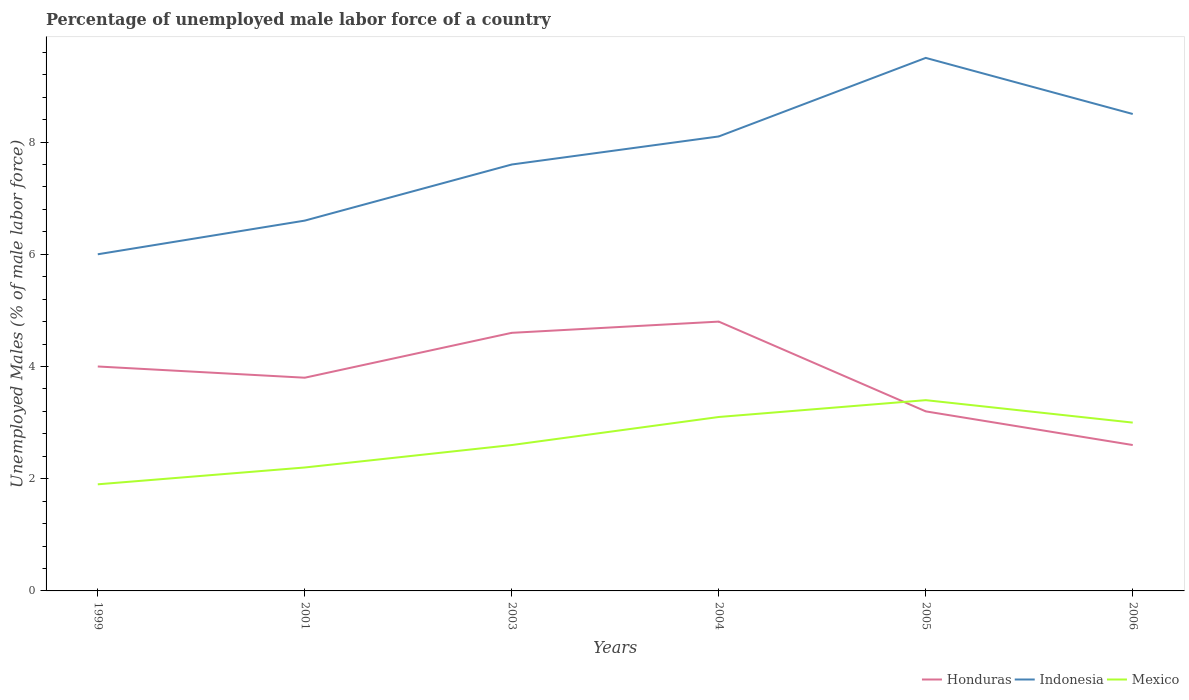Does the line corresponding to Mexico intersect with the line corresponding to Honduras?
Your response must be concise. Yes. Is the number of lines equal to the number of legend labels?
Your response must be concise. Yes. Across all years, what is the maximum percentage of unemployed male labor force in Honduras?
Your answer should be very brief. 2.6. In which year was the percentage of unemployed male labor force in Indonesia maximum?
Your answer should be very brief. 1999. What is the total percentage of unemployed male labor force in Indonesia in the graph?
Make the answer very short. -0.5. What is the difference between the highest and the second highest percentage of unemployed male labor force in Indonesia?
Offer a terse response. 3.5. What is the difference between the highest and the lowest percentage of unemployed male labor force in Mexico?
Your response must be concise. 3. What is the difference between two consecutive major ticks on the Y-axis?
Your answer should be very brief. 2. Does the graph contain any zero values?
Your answer should be very brief. No. Does the graph contain grids?
Make the answer very short. No. Where does the legend appear in the graph?
Offer a terse response. Bottom right. How many legend labels are there?
Give a very brief answer. 3. What is the title of the graph?
Your answer should be very brief. Percentage of unemployed male labor force of a country. What is the label or title of the X-axis?
Make the answer very short. Years. What is the label or title of the Y-axis?
Your response must be concise. Unemployed Males (% of male labor force). What is the Unemployed Males (% of male labor force) in Indonesia in 1999?
Make the answer very short. 6. What is the Unemployed Males (% of male labor force) of Mexico in 1999?
Your answer should be compact. 1.9. What is the Unemployed Males (% of male labor force) in Honduras in 2001?
Offer a very short reply. 3.8. What is the Unemployed Males (% of male labor force) in Indonesia in 2001?
Your answer should be compact. 6.6. What is the Unemployed Males (% of male labor force) in Mexico in 2001?
Provide a short and direct response. 2.2. What is the Unemployed Males (% of male labor force) of Honduras in 2003?
Provide a succinct answer. 4.6. What is the Unemployed Males (% of male labor force) of Indonesia in 2003?
Your answer should be compact. 7.6. What is the Unemployed Males (% of male labor force) of Mexico in 2003?
Your answer should be compact. 2.6. What is the Unemployed Males (% of male labor force) in Honduras in 2004?
Provide a succinct answer. 4.8. What is the Unemployed Males (% of male labor force) in Indonesia in 2004?
Your answer should be very brief. 8.1. What is the Unemployed Males (% of male labor force) of Mexico in 2004?
Make the answer very short. 3.1. What is the Unemployed Males (% of male labor force) in Honduras in 2005?
Ensure brevity in your answer.  3.2. What is the Unemployed Males (% of male labor force) in Mexico in 2005?
Make the answer very short. 3.4. What is the Unemployed Males (% of male labor force) in Honduras in 2006?
Provide a succinct answer. 2.6. What is the Unemployed Males (% of male labor force) of Indonesia in 2006?
Provide a succinct answer. 8.5. What is the Unemployed Males (% of male labor force) in Mexico in 2006?
Your answer should be compact. 3. Across all years, what is the maximum Unemployed Males (% of male labor force) of Honduras?
Make the answer very short. 4.8. Across all years, what is the maximum Unemployed Males (% of male labor force) in Indonesia?
Provide a succinct answer. 9.5. Across all years, what is the maximum Unemployed Males (% of male labor force) in Mexico?
Your answer should be very brief. 3.4. Across all years, what is the minimum Unemployed Males (% of male labor force) in Honduras?
Provide a succinct answer. 2.6. Across all years, what is the minimum Unemployed Males (% of male labor force) of Indonesia?
Give a very brief answer. 6. Across all years, what is the minimum Unemployed Males (% of male labor force) in Mexico?
Make the answer very short. 1.9. What is the total Unemployed Males (% of male labor force) of Honduras in the graph?
Your response must be concise. 23. What is the total Unemployed Males (% of male labor force) of Indonesia in the graph?
Give a very brief answer. 46.3. What is the total Unemployed Males (% of male labor force) in Mexico in the graph?
Ensure brevity in your answer.  16.2. What is the difference between the Unemployed Males (% of male labor force) of Honduras in 1999 and that in 2003?
Offer a terse response. -0.6. What is the difference between the Unemployed Males (% of male labor force) in Indonesia in 1999 and that in 2004?
Offer a terse response. -2.1. What is the difference between the Unemployed Males (% of male labor force) of Honduras in 1999 and that in 2005?
Your answer should be very brief. 0.8. What is the difference between the Unemployed Males (% of male labor force) in Honduras in 1999 and that in 2006?
Provide a short and direct response. 1.4. What is the difference between the Unemployed Males (% of male labor force) of Honduras in 2001 and that in 2003?
Ensure brevity in your answer.  -0.8. What is the difference between the Unemployed Males (% of male labor force) in Indonesia in 2001 and that in 2003?
Offer a terse response. -1. What is the difference between the Unemployed Males (% of male labor force) of Mexico in 2001 and that in 2004?
Your answer should be compact. -0.9. What is the difference between the Unemployed Males (% of male labor force) in Honduras in 2001 and that in 2006?
Your answer should be compact. 1.2. What is the difference between the Unemployed Males (% of male labor force) of Indonesia in 2001 and that in 2006?
Give a very brief answer. -1.9. What is the difference between the Unemployed Males (% of male labor force) in Honduras in 2003 and that in 2004?
Give a very brief answer. -0.2. What is the difference between the Unemployed Males (% of male labor force) in Indonesia in 2003 and that in 2004?
Provide a short and direct response. -0.5. What is the difference between the Unemployed Males (% of male labor force) in Indonesia in 2003 and that in 2005?
Your answer should be compact. -1.9. What is the difference between the Unemployed Males (% of male labor force) of Honduras in 2003 and that in 2006?
Offer a very short reply. 2. What is the difference between the Unemployed Males (% of male labor force) in Indonesia in 2003 and that in 2006?
Give a very brief answer. -0.9. What is the difference between the Unemployed Males (% of male labor force) of Mexico in 2003 and that in 2006?
Your answer should be very brief. -0.4. What is the difference between the Unemployed Males (% of male labor force) in Indonesia in 2004 and that in 2005?
Provide a succinct answer. -1.4. What is the difference between the Unemployed Males (% of male labor force) of Mexico in 2004 and that in 2005?
Offer a very short reply. -0.3. What is the difference between the Unemployed Males (% of male labor force) in Mexico in 2004 and that in 2006?
Your answer should be compact. 0.1. What is the difference between the Unemployed Males (% of male labor force) of Honduras in 2005 and that in 2006?
Provide a succinct answer. 0.6. What is the difference between the Unemployed Males (% of male labor force) of Indonesia in 2005 and that in 2006?
Your answer should be compact. 1. What is the difference between the Unemployed Males (% of male labor force) of Honduras in 1999 and the Unemployed Males (% of male labor force) of Mexico in 2001?
Provide a succinct answer. 1.8. What is the difference between the Unemployed Males (% of male labor force) in Indonesia in 1999 and the Unemployed Males (% of male labor force) in Mexico in 2001?
Your response must be concise. 3.8. What is the difference between the Unemployed Males (% of male labor force) of Honduras in 1999 and the Unemployed Males (% of male labor force) of Indonesia in 2003?
Give a very brief answer. -3.6. What is the difference between the Unemployed Males (% of male labor force) of Honduras in 1999 and the Unemployed Males (% of male labor force) of Mexico in 2003?
Your response must be concise. 1.4. What is the difference between the Unemployed Males (% of male labor force) in Honduras in 1999 and the Unemployed Males (% of male labor force) in Indonesia in 2004?
Ensure brevity in your answer.  -4.1. What is the difference between the Unemployed Males (% of male labor force) in Honduras in 1999 and the Unemployed Males (% of male labor force) in Mexico in 2004?
Keep it short and to the point. 0.9. What is the difference between the Unemployed Males (% of male labor force) of Indonesia in 1999 and the Unemployed Males (% of male labor force) of Mexico in 2004?
Your response must be concise. 2.9. What is the difference between the Unemployed Males (% of male labor force) of Honduras in 1999 and the Unemployed Males (% of male labor force) of Mexico in 2005?
Keep it short and to the point. 0.6. What is the difference between the Unemployed Males (% of male labor force) of Indonesia in 1999 and the Unemployed Males (% of male labor force) of Mexico in 2005?
Offer a very short reply. 2.6. What is the difference between the Unemployed Males (% of male labor force) in Honduras in 1999 and the Unemployed Males (% of male labor force) in Indonesia in 2006?
Your answer should be compact. -4.5. What is the difference between the Unemployed Males (% of male labor force) in Honduras in 1999 and the Unemployed Males (% of male labor force) in Mexico in 2006?
Your answer should be compact. 1. What is the difference between the Unemployed Males (% of male labor force) in Indonesia in 1999 and the Unemployed Males (% of male labor force) in Mexico in 2006?
Make the answer very short. 3. What is the difference between the Unemployed Males (% of male labor force) in Indonesia in 2001 and the Unemployed Males (% of male labor force) in Mexico in 2003?
Offer a very short reply. 4. What is the difference between the Unemployed Males (% of male labor force) in Honduras in 2001 and the Unemployed Males (% of male labor force) in Indonesia in 2004?
Your answer should be compact. -4.3. What is the difference between the Unemployed Males (% of male labor force) of Honduras in 2001 and the Unemployed Males (% of male labor force) of Mexico in 2004?
Your answer should be compact. 0.7. What is the difference between the Unemployed Males (% of male labor force) of Honduras in 2001 and the Unemployed Males (% of male labor force) of Indonesia in 2005?
Offer a very short reply. -5.7. What is the difference between the Unemployed Males (% of male labor force) of Honduras in 2001 and the Unemployed Males (% of male labor force) of Mexico in 2005?
Your response must be concise. 0.4. What is the difference between the Unemployed Males (% of male labor force) in Indonesia in 2001 and the Unemployed Males (% of male labor force) in Mexico in 2005?
Ensure brevity in your answer.  3.2. What is the difference between the Unemployed Males (% of male labor force) of Honduras in 2001 and the Unemployed Males (% of male labor force) of Indonesia in 2006?
Make the answer very short. -4.7. What is the difference between the Unemployed Males (% of male labor force) in Honduras in 2001 and the Unemployed Males (% of male labor force) in Mexico in 2006?
Keep it short and to the point. 0.8. What is the difference between the Unemployed Males (% of male labor force) in Indonesia in 2001 and the Unemployed Males (% of male labor force) in Mexico in 2006?
Provide a short and direct response. 3.6. What is the difference between the Unemployed Males (% of male labor force) in Honduras in 2003 and the Unemployed Males (% of male labor force) in Indonesia in 2004?
Your response must be concise. -3.5. What is the difference between the Unemployed Males (% of male labor force) in Indonesia in 2003 and the Unemployed Males (% of male labor force) in Mexico in 2004?
Your answer should be compact. 4.5. What is the difference between the Unemployed Males (% of male labor force) of Honduras in 2003 and the Unemployed Males (% of male labor force) of Mexico in 2005?
Make the answer very short. 1.2. What is the difference between the Unemployed Males (% of male labor force) of Honduras in 2003 and the Unemployed Males (% of male labor force) of Indonesia in 2006?
Make the answer very short. -3.9. What is the difference between the Unemployed Males (% of male labor force) in Honduras in 2003 and the Unemployed Males (% of male labor force) in Mexico in 2006?
Keep it short and to the point. 1.6. What is the difference between the Unemployed Males (% of male labor force) in Indonesia in 2003 and the Unemployed Males (% of male labor force) in Mexico in 2006?
Make the answer very short. 4.6. What is the difference between the Unemployed Males (% of male labor force) in Honduras in 2004 and the Unemployed Males (% of male labor force) in Indonesia in 2005?
Ensure brevity in your answer.  -4.7. What is the difference between the Unemployed Males (% of male labor force) in Honduras in 2004 and the Unemployed Males (% of male labor force) in Mexico in 2006?
Your response must be concise. 1.8. What is the difference between the Unemployed Males (% of male labor force) in Indonesia in 2004 and the Unemployed Males (% of male labor force) in Mexico in 2006?
Ensure brevity in your answer.  5.1. What is the average Unemployed Males (% of male labor force) of Honduras per year?
Ensure brevity in your answer.  3.83. What is the average Unemployed Males (% of male labor force) of Indonesia per year?
Your answer should be very brief. 7.72. What is the average Unemployed Males (% of male labor force) of Mexico per year?
Offer a very short reply. 2.7. In the year 1999, what is the difference between the Unemployed Males (% of male labor force) in Honduras and Unemployed Males (% of male labor force) in Indonesia?
Your answer should be very brief. -2. In the year 1999, what is the difference between the Unemployed Males (% of male labor force) of Honduras and Unemployed Males (% of male labor force) of Mexico?
Offer a terse response. 2.1. In the year 2001, what is the difference between the Unemployed Males (% of male labor force) in Honduras and Unemployed Males (% of male labor force) in Indonesia?
Provide a short and direct response. -2.8. In the year 2003, what is the difference between the Unemployed Males (% of male labor force) in Honduras and Unemployed Males (% of male labor force) in Indonesia?
Give a very brief answer. -3. In the year 2003, what is the difference between the Unemployed Males (% of male labor force) in Indonesia and Unemployed Males (% of male labor force) in Mexico?
Keep it short and to the point. 5. In the year 2004, what is the difference between the Unemployed Males (% of male labor force) in Honduras and Unemployed Males (% of male labor force) in Indonesia?
Provide a short and direct response. -3.3. In the year 2004, what is the difference between the Unemployed Males (% of male labor force) in Honduras and Unemployed Males (% of male labor force) in Mexico?
Ensure brevity in your answer.  1.7. In the year 2004, what is the difference between the Unemployed Males (% of male labor force) of Indonesia and Unemployed Males (% of male labor force) of Mexico?
Your answer should be very brief. 5. In the year 2005, what is the difference between the Unemployed Males (% of male labor force) in Indonesia and Unemployed Males (% of male labor force) in Mexico?
Your response must be concise. 6.1. In the year 2006, what is the difference between the Unemployed Males (% of male labor force) of Indonesia and Unemployed Males (% of male labor force) of Mexico?
Provide a succinct answer. 5.5. What is the ratio of the Unemployed Males (% of male labor force) in Honduras in 1999 to that in 2001?
Offer a very short reply. 1.05. What is the ratio of the Unemployed Males (% of male labor force) in Mexico in 1999 to that in 2001?
Offer a terse response. 0.86. What is the ratio of the Unemployed Males (% of male labor force) in Honduras in 1999 to that in 2003?
Make the answer very short. 0.87. What is the ratio of the Unemployed Males (% of male labor force) in Indonesia in 1999 to that in 2003?
Your answer should be very brief. 0.79. What is the ratio of the Unemployed Males (% of male labor force) of Mexico in 1999 to that in 2003?
Provide a succinct answer. 0.73. What is the ratio of the Unemployed Males (% of male labor force) of Indonesia in 1999 to that in 2004?
Make the answer very short. 0.74. What is the ratio of the Unemployed Males (% of male labor force) of Mexico in 1999 to that in 2004?
Ensure brevity in your answer.  0.61. What is the ratio of the Unemployed Males (% of male labor force) in Honduras in 1999 to that in 2005?
Provide a succinct answer. 1.25. What is the ratio of the Unemployed Males (% of male labor force) of Indonesia in 1999 to that in 2005?
Keep it short and to the point. 0.63. What is the ratio of the Unemployed Males (% of male labor force) of Mexico in 1999 to that in 2005?
Your answer should be very brief. 0.56. What is the ratio of the Unemployed Males (% of male labor force) of Honduras in 1999 to that in 2006?
Ensure brevity in your answer.  1.54. What is the ratio of the Unemployed Males (% of male labor force) in Indonesia in 1999 to that in 2006?
Give a very brief answer. 0.71. What is the ratio of the Unemployed Males (% of male labor force) of Mexico in 1999 to that in 2006?
Keep it short and to the point. 0.63. What is the ratio of the Unemployed Males (% of male labor force) in Honduras in 2001 to that in 2003?
Provide a succinct answer. 0.83. What is the ratio of the Unemployed Males (% of male labor force) of Indonesia in 2001 to that in 2003?
Offer a terse response. 0.87. What is the ratio of the Unemployed Males (% of male labor force) in Mexico in 2001 to that in 2003?
Ensure brevity in your answer.  0.85. What is the ratio of the Unemployed Males (% of male labor force) in Honduras in 2001 to that in 2004?
Keep it short and to the point. 0.79. What is the ratio of the Unemployed Males (% of male labor force) of Indonesia in 2001 to that in 2004?
Offer a terse response. 0.81. What is the ratio of the Unemployed Males (% of male labor force) of Mexico in 2001 to that in 2004?
Your answer should be very brief. 0.71. What is the ratio of the Unemployed Males (% of male labor force) in Honduras in 2001 to that in 2005?
Your answer should be compact. 1.19. What is the ratio of the Unemployed Males (% of male labor force) in Indonesia in 2001 to that in 2005?
Ensure brevity in your answer.  0.69. What is the ratio of the Unemployed Males (% of male labor force) in Mexico in 2001 to that in 2005?
Give a very brief answer. 0.65. What is the ratio of the Unemployed Males (% of male labor force) in Honduras in 2001 to that in 2006?
Provide a succinct answer. 1.46. What is the ratio of the Unemployed Males (% of male labor force) of Indonesia in 2001 to that in 2006?
Your answer should be very brief. 0.78. What is the ratio of the Unemployed Males (% of male labor force) of Mexico in 2001 to that in 2006?
Give a very brief answer. 0.73. What is the ratio of the Unemployed Males (% of male labor force) in Honduras in 2003 to that in 2004?
Give a very brief answer. 0.96. What is the ratio of the Unemployed Males (% of male labor force) of Indonesia in 2003 to that in 2004?
Your answer should be very brief. 0.94. What is the ratio of the Unemployed Males (% of male labor force) in Mexico in 2003 to that in 2004?
Your answer should be compact. 0.84. What is the ratio of the Unemployed Males (% of male labor force) in Honduras in 2003 to that in 2005?
Your answer should be very brief. 1.44. What is the ratio of the Unemployed Males (% of male labor force) in Mexico in 2003 to that in 2005?
Give a very brief answer. 0.76. What is the ratio of the Unemployed Males (% of male labor force) in Honduras in 2003 to that in 2006?
Keep it short and to the point. 1.77. What is the ratio of the Unemployed Males (% of male labor force) of Indonesia in 2003 to that in 2006?
Ensure brevity in your answer.  0.89. What is the ratio of the Unemployed Males (% of male labor force) in Mexico in 2003 to that in 2006?
Offer a very short reply. 0.87. What is the ratio of the Unemployed Males (% of male labor force) in Indonesia in 2004 to that in 2005?
Provide a short and direct response. 0.85. What is the ratio of the Unemployed Males (% of male labor force) in Mexico in 2004 to that in 2005?
Your answer should be very brief. 0.91. What is the ratio of the Unemployed Males (% of male labor force) in Honduras in 2004 to that in 2006?
Make the answer very short. 1.85. What is the ratio of the Unemployed Males (% of male labor force) of Indonesia in 2004 to that in 2006?
Keep it short and to the point. 0.95. What is the ratio of the Unemployed Males (% of male labor force) of Mexico in 2004 to that in 2006?
Offer a terse response. 1.03. What is the ratio of the Unemployed Males (% of male labor force) in Honduras in 2005 to that in 2006?
Your response must be concise. 1.23. What is the ratio of the Unemployed Males (% of male labor force) in Indonesia in 2005 to that in 2006?
Keep it short and to the point. 1.12. What is the ratio of the Unemployed Males (% of male labor force) of Mexico in 2005 to that in 2006?
Your answer should be very brief. 1.13. What is the difference between the highest and the second highest Unemployed Males (% of male labor force) of Indonesia?
Offer a terse response. 1. What is the difference between the highest and the second highest Unemployed Males (% of male labor force) in Mexico?
Ensure brevity in your answer.  0.3. What is the difference between the highest and the lowest Unemployed Males (% of male labor force) of Honduras?
Your answer should be compact. 2.2. What is the difference between the highest and the lowest Unemployed Males (% of male labor force) in Indonesia?
Provide a succinct answer. 3.5. What is the difference between the highest and the lowest Unemployed Males (% of male labor force) in Mexico?
Make the answer very short. 1.5. 